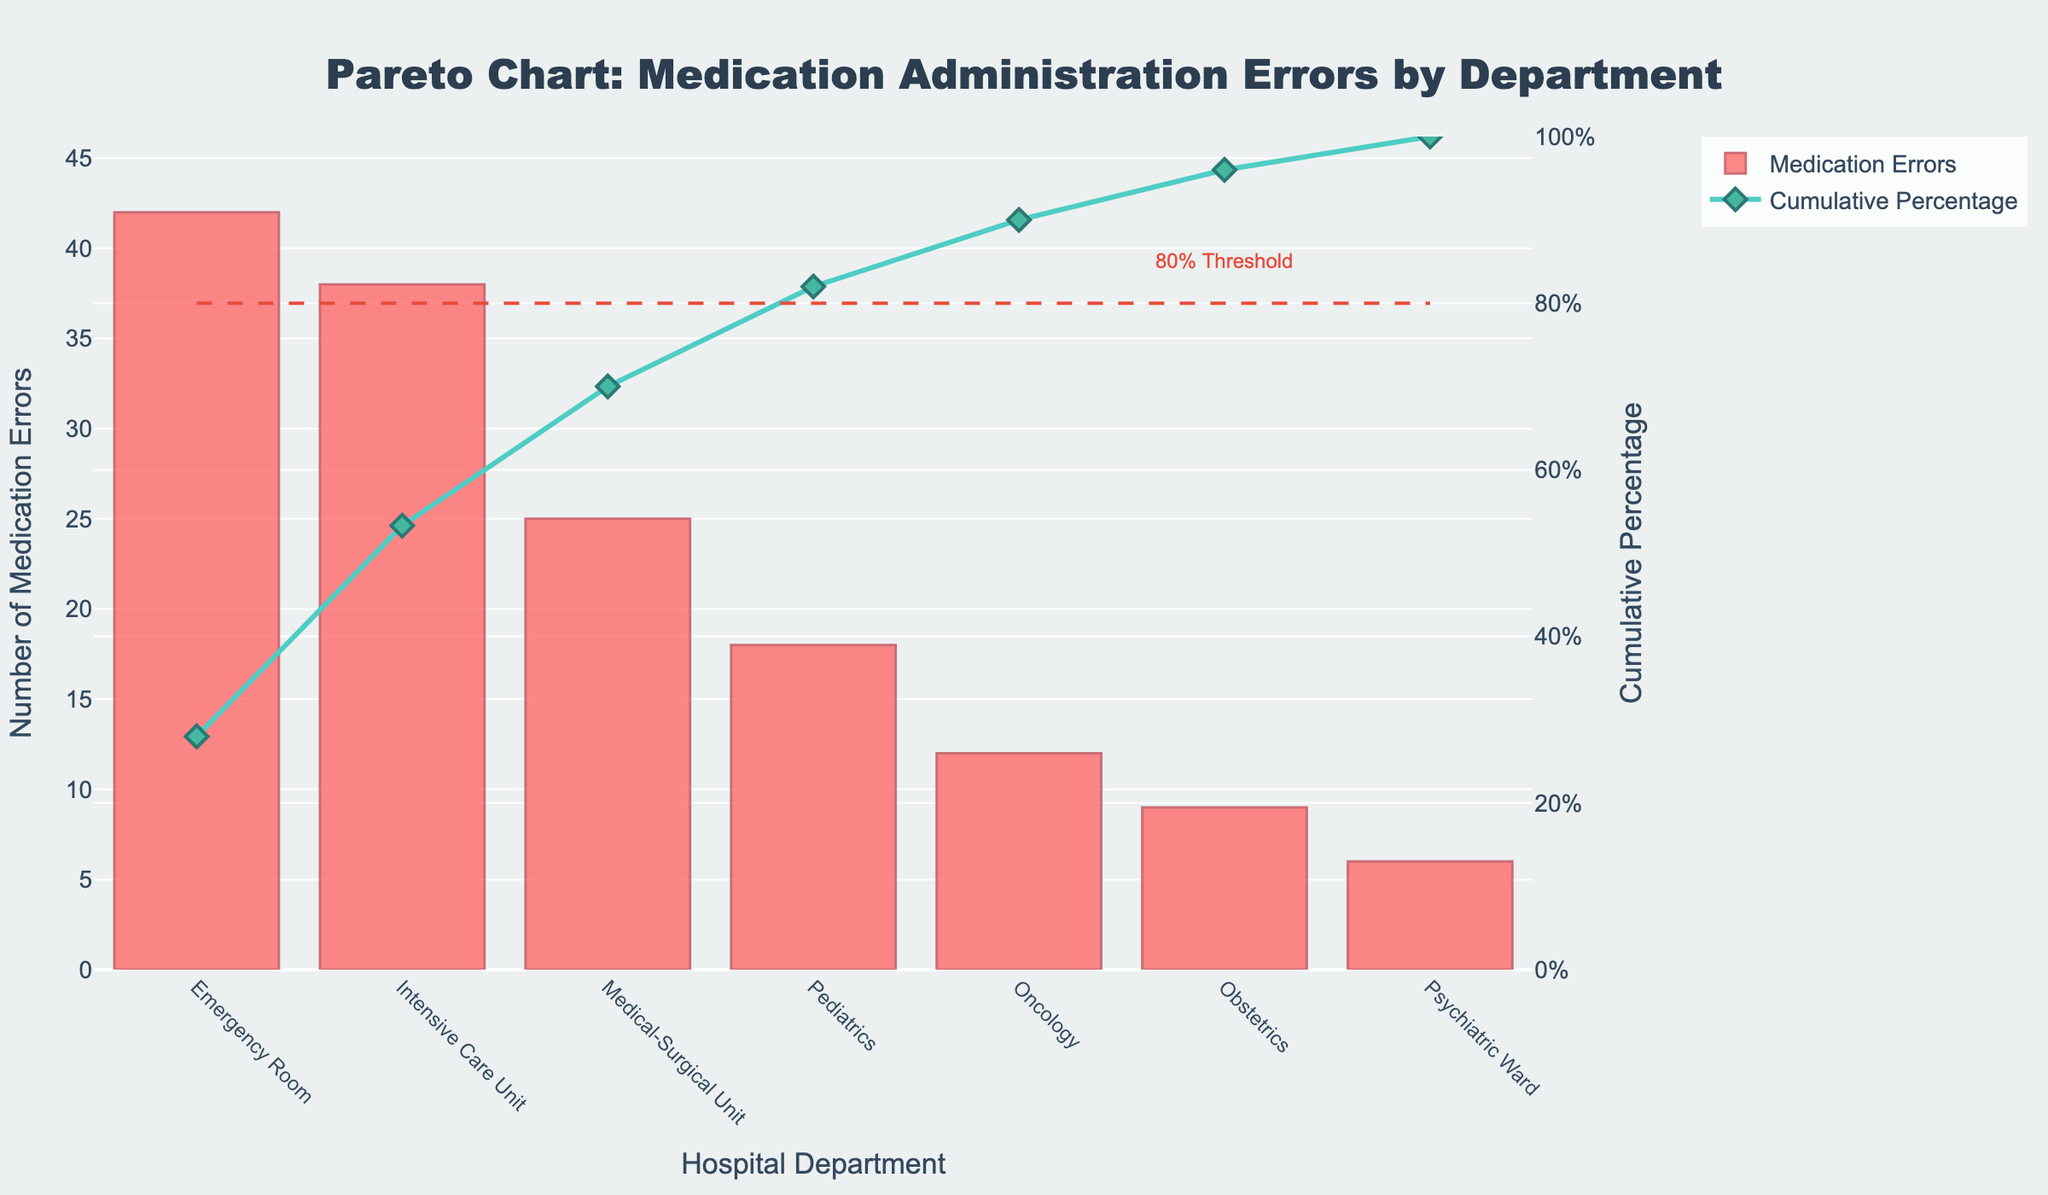What's the title of the chart? The title is usually found at the top center of the chart. This one reads "Pareto Chart: Medication Administration Errors by Department".
Answer: Pareto Chart: Medication Administration Errors by Department Which department has the highest number of medication errors? The department with the tallest bar represents the highest number of medication errors, which is the Emergency Room with 42 errors.
Answer: Emergency Room What is the cumulative percentage of medication errors after including the Medical-Surgical Unit? The cumulative percentage is found by following the line plot at the point for the Medical-Surgical Unit, which is 70.0%.
Answer: 70.0% How many more errors does the Emergency Room have compared to the Pediatrics department? To find the difference: 42 (Emergency Room) - 18 (Pediatrics) = 24.
Answer: 24 What is the percentage increase in cumulative errors from the Intensive Care Unit to the Oncology department? Percentage increase is calculated as follows: (82 - 53.3) = 28.7%.
Answer: 28.7% Which departments contribute to 80% of the cumulative medication errors? The cumulative percentage for the first three departments (Emergency Room, Intensive Care Unit, Medical-Surgical Unit) sums up to 70%, and adding Pediatrics brings it to 82%. Therefore, these four departments contribute to 80%.
Answer: Emergency Room, Intensive Care Unit, Medical-Surgical Unit, Pediatrics What color represents the cumulative percentage line? The cumulative percentage line is colored turquoise as indicated by the line and markers in the chart.
Answer: Turquoise By how much does the number of errors decrease from the Intensive Care Unit to the Oncology department? Subtract the errors in Oncology from those in the Intensive Care Unit: 38 - 12 = 26 errors.
Answer: 26 Which department is just below the 80% cumulative threshold mark? The Pediatrics department is just below the horizontal 80% line which is confirmed by the data showing its cumulative percentage at 82%.
Answer: Pediatrics What is the y-axis title for the bars representing the number of medication errors? The y-axis title for the bars can be seen on the left side of the chart and reads "Number of Medication Errors".
Answer: Number of Medication Errors 